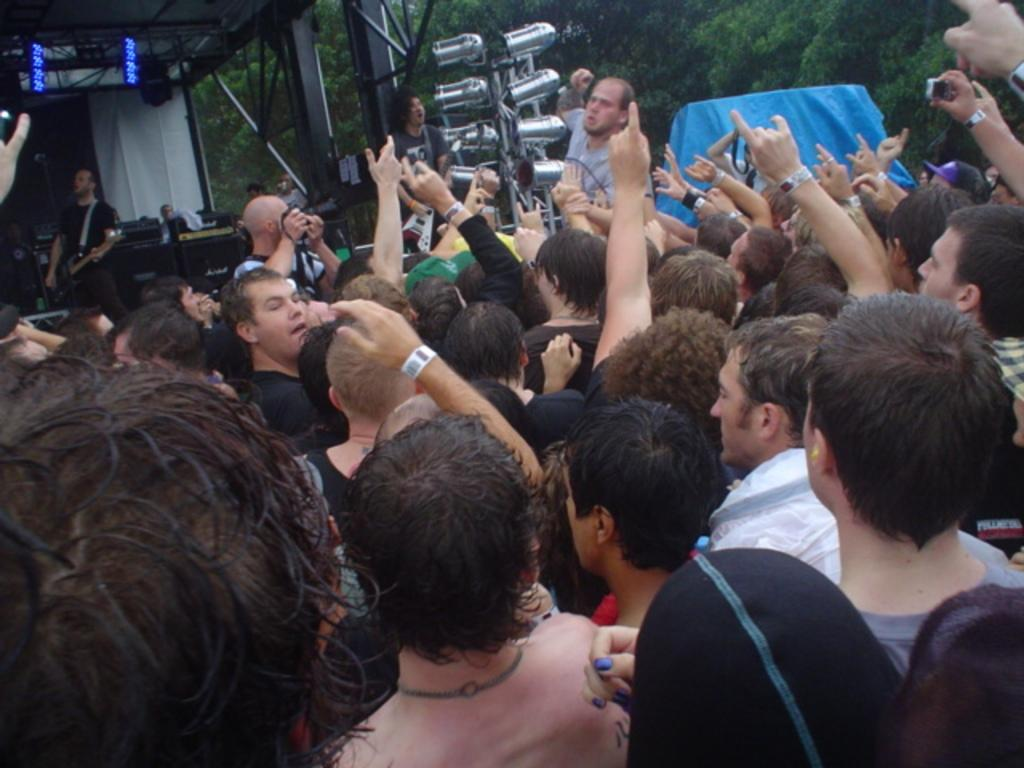What is happening in the image? There is a group of people standing in the image. Can you describe the shelter in the image? There is a shelter with iron rods in the top left side of the image. What can be seen in the background of the image? There are trees and a blue tarpaulin in the background of the image. What type of interest does the carpenter have in the design of the shelter? There is no carpenter present in the image, nor is there any information about the design of the shelter. 